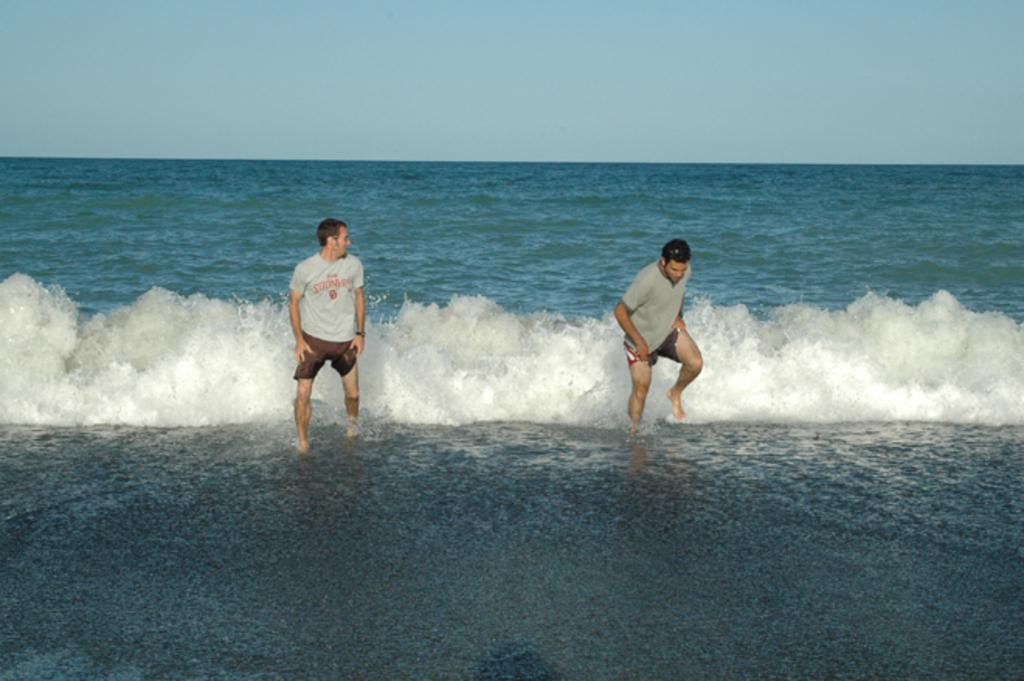How many people are in the water in the image? There are two people in the water in the image. What can be seen in the background of the image? The sky is visible in the background of the image. What type of beetle is crawling on the shoulder of the person in the water? There is no beetle present in the image; it only shows two people in the water and the sky in the background. 